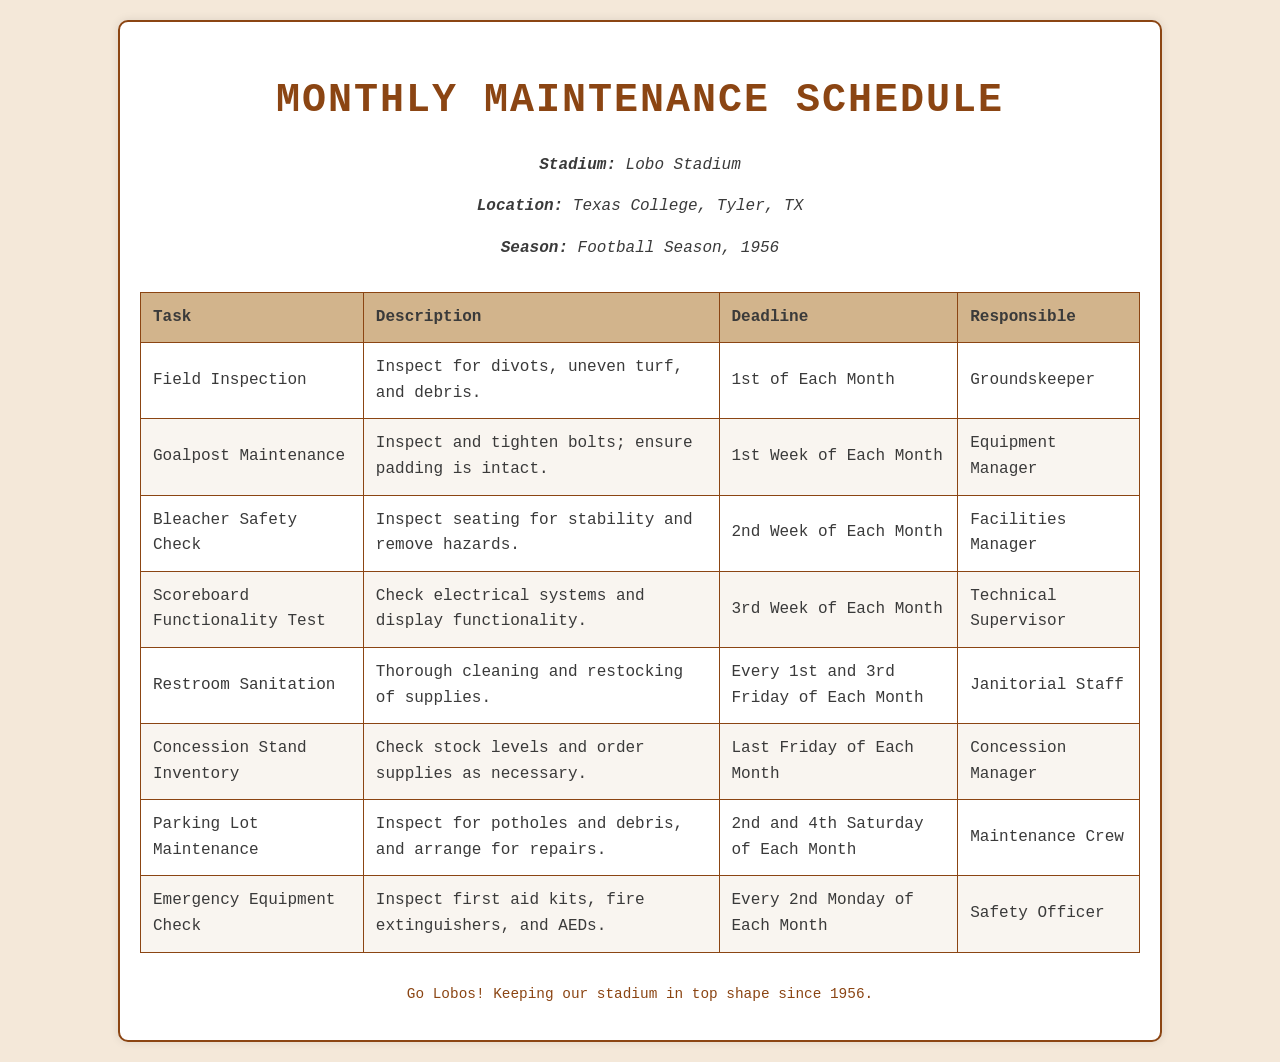What is the name of the stadium? The name of the stadium is mentioned in the document header information.
Answer: Lobo Stadium What is the location of the stadium? The location is specified in the same header section of the document.
Answer: Texas College, Tyler, TX When is the deadline for the Field Inspection? The document clearly states the deadline in the task row of the table.
Answer: 1st of Each Month Who is responsible for the Goalpost Maintenance? The responsible person is listed in the table next to the task.
Answer: Equipment Manager What task is performed every 2nd Monday of each month? The document specifies this task under the relevant row in the table.
Answer: Emergency Equipment Check How often should the restroom sanitation be performed? The document indicates the frequency in the task description.
Answer: Every 1st and 3rd Friday of Each Month What week of each month is the scoreboard functionality test due? The document specifies this in the deadline column for the relevant task.
Answer: 3rd Week of Each Month Which task requires checking stock levels at the concession stand? The task is listed in the table, including a description relating to stock levels.
Answer: Concession Stand Inventory What is the deadline for parking lot maintenance inspections? The schedule details this in the respective task row of the table.
Answer: 2nd and 4th Saturday of Each Month 